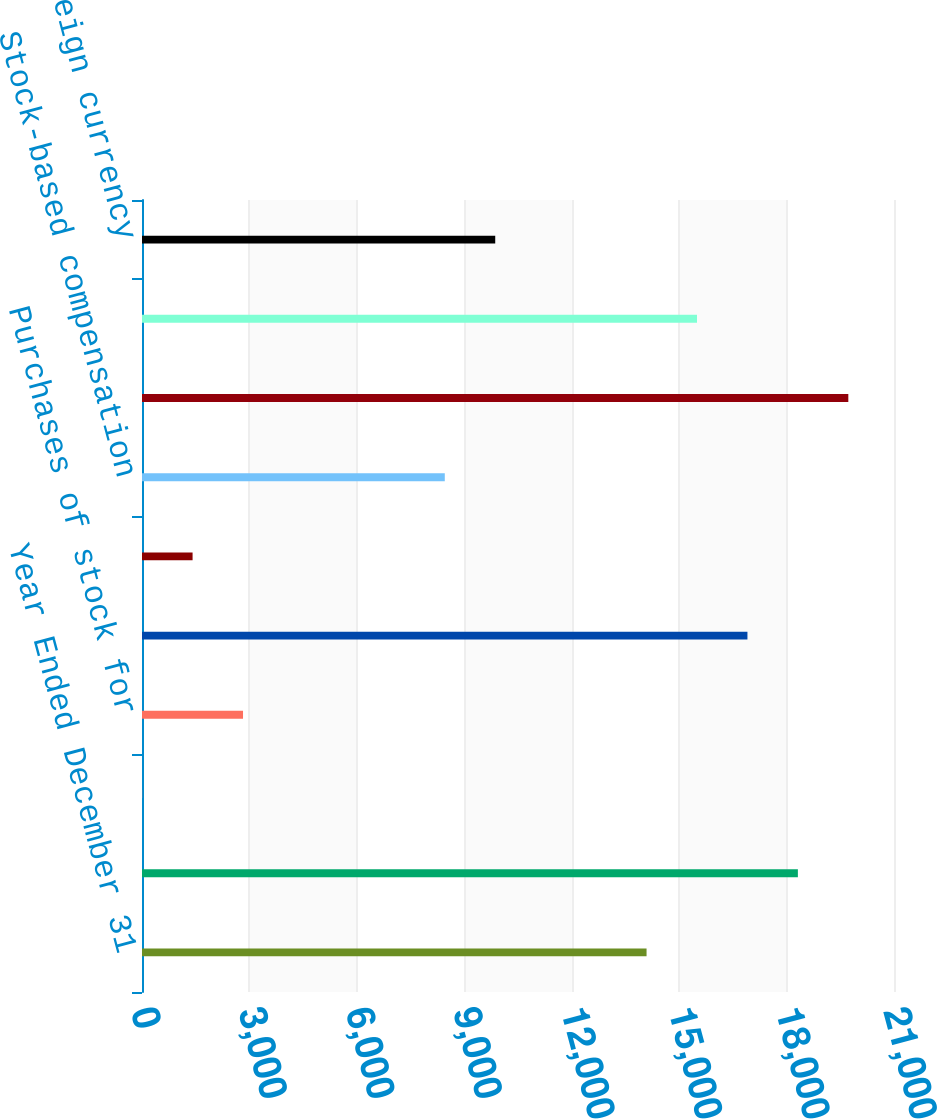<chart> <loc_0><loc_0><loc_500><loc_500><bar_chart><fcel>Year Ended December 31<fcel>Balance at beginning of year<fcel>Stock issued to employees<fcel>Purchases of stock for<fcel>Balance at end of year<fcel>Tax benefit from employees'<fcel>Stock-based compensation<fcel>Net income<fcel>Dividends (per share-100 088<fcel>Net foreign currency<nl><fcel>14090<fcel>18315.8<fcel>4<fcel>2821.2<fcel>16907.2<fcel>1412.6<fcel>8455.6<fcel>19724.4<fcel>15498.6<fcel>9864.2<nl></chart> 